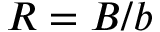<formula> <loc_0><loc_0><loc_500><loc_500>R = B / b</formula> 